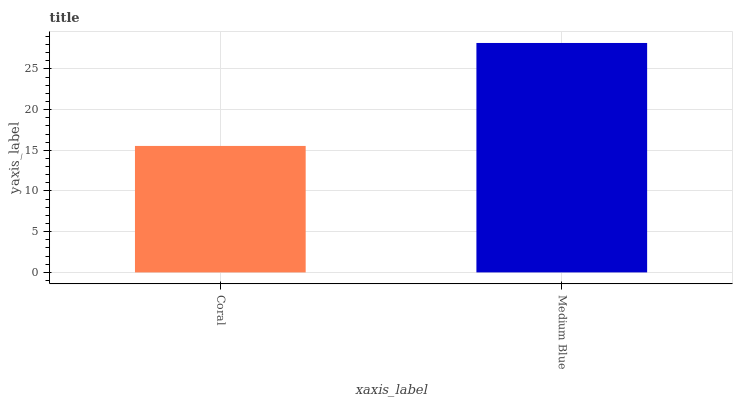Is Coral the minimum?
Answer yes or no. Yes. Is Medium Blue the maximum?
Answer yes or no. Yes. Is Medium Blue the minimum?
Answer yes or no. No. Is Medium Blue greater than Coral?
Answer yes or no. Yes. Is Coral less than Medium Blue?
Answer yes or no. Yes. Is Coral greater than Medium Blue?
Answer yes or no. No. Is Medium Blue less than Coral?
Answer yes or no. No. Is Medium Blue the high median?
Answer yes or no. Yes. Is Coral the low median?
Answer yes or no. Yes. Is Coral the high median?
Answer yes or no. No. Is Medium Blue the low median?
Answer yes or no. No. 